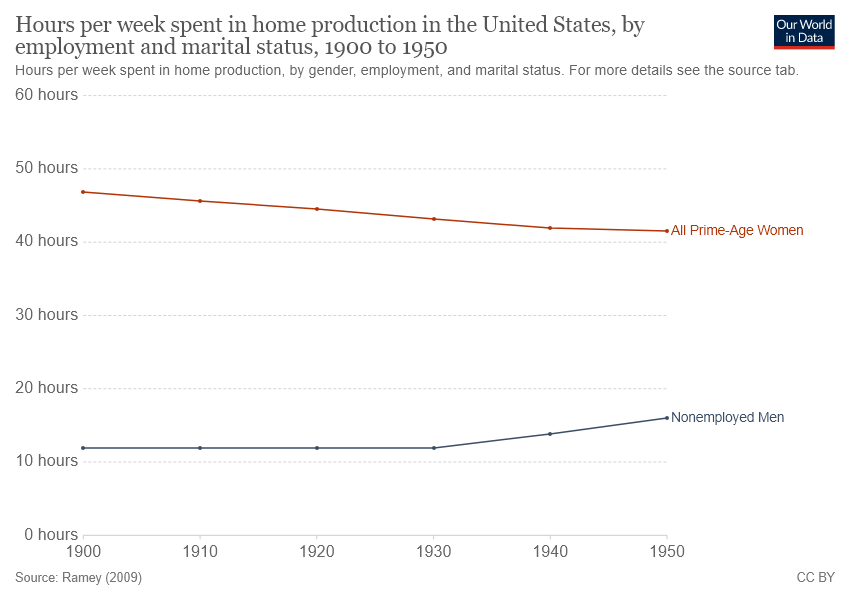Mention a couple of crucial points in this snapshot. The gap between the two lines reaches its peak in 1900. The brown line represents all prime-age women in the United States, including their employment rate and trends from 2000 to 2020. 